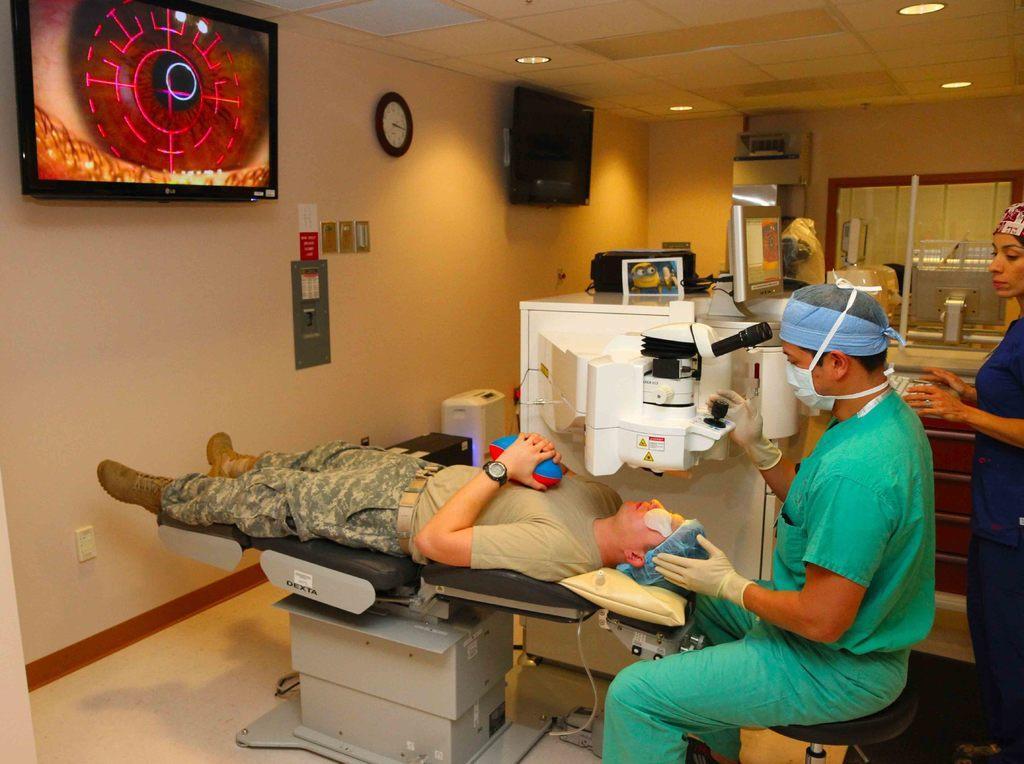Could you give a brief overview of what you see in this image? The man in the uniform who is lying on the chair is under treatment. Beside him, we see a man in green shirt is sitting on the stool. Beside him, we see machinery equipment. In front of him, we see a white wall on which television and watch are placed. In the background, we see a window. This picture is clicked in the hospital. 